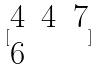Convert formula to latex. <formula><loc_0><loc_0><loc_500><loc_500>[ \begin{matrix} 4 & 4 & 7 \\ 6 \end{matrix} ]</formula> 